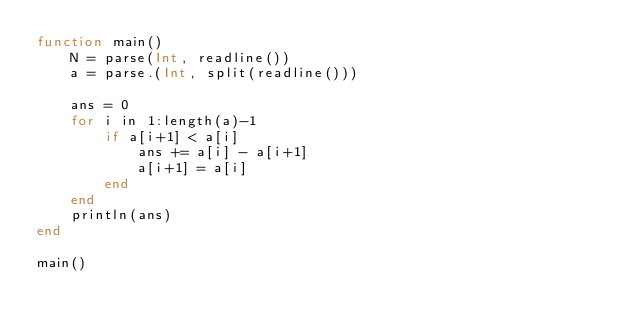Convert code to text. <code><loc_0><loc_0><loc_500><loc_500><_Julia_>function main()
    N = parse(Int, readline())
    a = parse.(Int, split(readline()))

    ans = 0
    for i in 1:length(a)-1
        if a[i+1] < a[i]
            ans += a[i] - a[i+1]
            a[i+1] = a[i] 
        end
    end
    println(ans)
end

main()</code> 